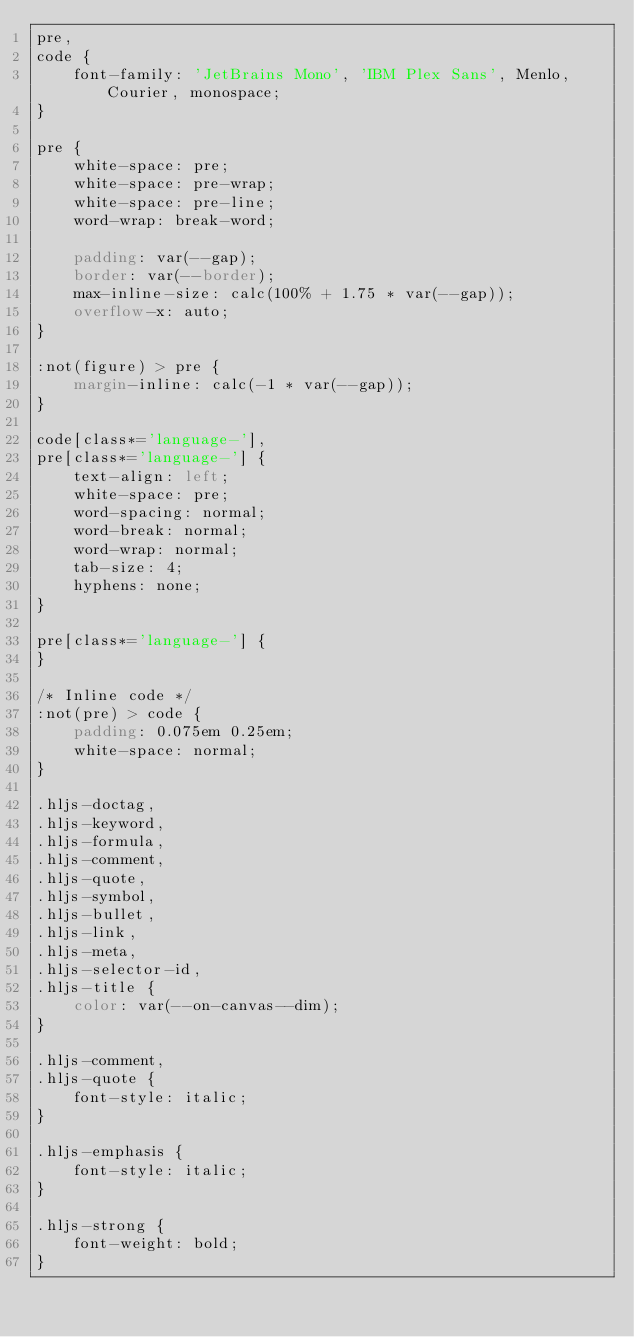<code> <loc_0><loc_0><loc_500><loc_500><_CSS_>pre,
code {
    font-family: 'JetBrains Mono', 'IBM Plex Sans', Menlo, Courier, monospace;
}

pre {
    white-space: pre;
    white-space: pre-wrap;
    white-space: pre-line;
    word-wrap: break-word;

    padding: var(--gap);
    border: var(--border);
    max-inline-size: calc(100% + 1.75 * var(--gap));
    overflow-x: auto;
}

:not(figure) > pre {
    margin-inline: calc(-1 * var(--gap));
}

code[class*='language-'],
pre[class*='language-'] {
    text-align: left;
    white-space: pre;
    word-spacing: normal;
    word-break: normal;
    word-wrap: normal;
    tab-size: 4;
    hyphens: none;
}

pre[class*='language-'] {
}

/* Inline code */
:not(pre) > code {
    padding: 0.075em 0.25em;
    white-space: normal;
}

.hljs-doctag,
.hljs-keyword,
.hljs-formula,
.hljs-comment,
.hljs-quote,
.hljs-symbol,
.hljs-bullet,
.hljs-link,
.hljs-meta,
.hljs-selector-id,
.hljs-title {
    color: var(--on-canvas--dim);
}

.hljs-comment,
.hljs-quote {
    font-style: italic;
}

.hljs-emphasis {
    font-style: italic;
}

.hljs-strong {
    font-weight: bold;
}
</code> 